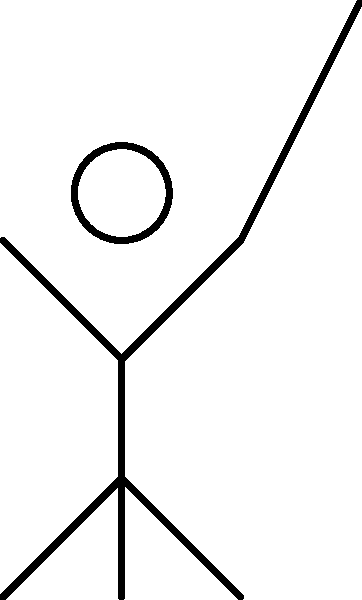In the biomechanical analysis of a golf swing, consider the stick figure diagram showing a golfer at the top of their backswing. Two force vectors are depicted: $\vec{F}_c$ representing the centripetal force of the club, and $\vec{F}_g$ representing the gravitational force on the club. If the angle $\theta$ between these forces is 45°, and the magnitude of $\vec{F}_g$ is 2 N, calculate the magnitude of the resultant force $\vec{F}_R$ acting on the club head, given that $|\vec{F}_c| = 8$ N. To solve this problem, we'll follow these steps:

1) First, we need to recognize that this is a vector addition problem. We're dealing with two force vectors at an angle to each other.

2) The resultant force $\vec{F}_R$ is the vector sum of $\vec{F}_c$ and $\vec{F}_g$.

3) To find the magnitude of the resultant force, we can use the law of cosines:

   $|\vec{F}_R|^2 = |\vec{F}_c|^2 + |\vec{F}_g|^2 - 2|\vec{F}_c||\vec{F}_g|\cos\theta$

4) We're given:
   $|\vec{F}_c| = 8$ N
   $|\vec{F}_g| = 2$ N
   $\theta = 45°$

5) Let's substitute these values into the equation:

   $|\vec{F}_R|^2 = 8^2 + 2^2 - 2(8)(2)\cos45°$

6) Simplify:
   $|\vec{F}_R|^2 = 64 + 4 - 16\cos45°$

7) $\cos45° = \frac{\sqrt{2}}{2}$, so:

   $|\vec{F}_R|^2 = 68 - 16(\frac{\sqrt{2}}{2})$

8) Simplify further:
   $|\vec{F}_R|^2 = 68 - 8\sqrt{2} \approx 56.69$

9) Take the square root of both sides:
   $|\vec{F}_R| = \sqrt{68 - 8\sqrt{2}} \approx 7.53$ N

Therefore, the magnitude of the resultant force is approximately 7.53 N.
Answer: 7.53 N 